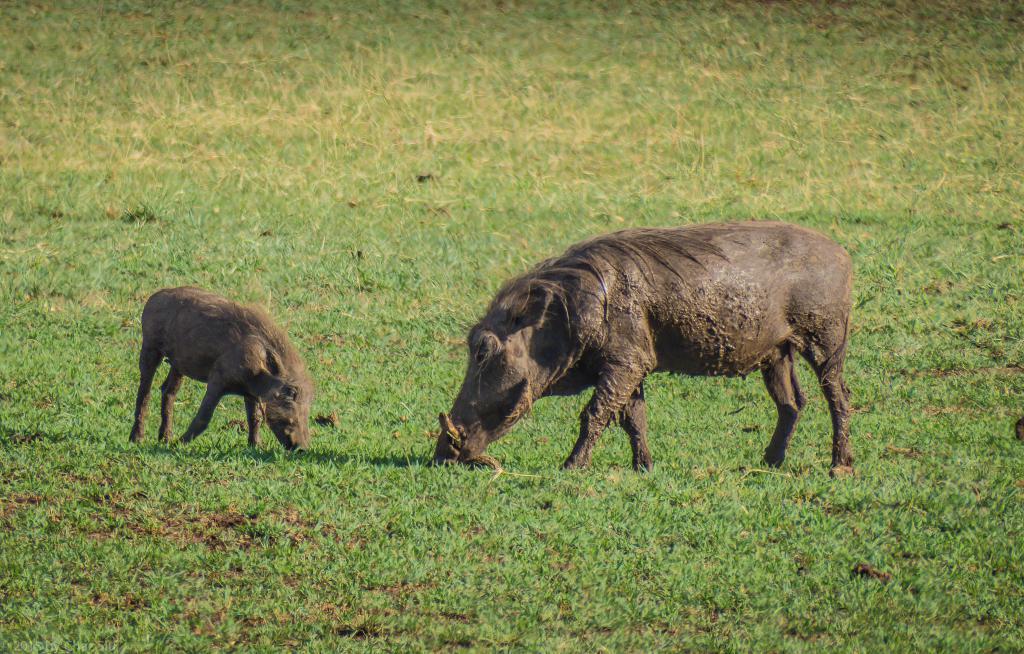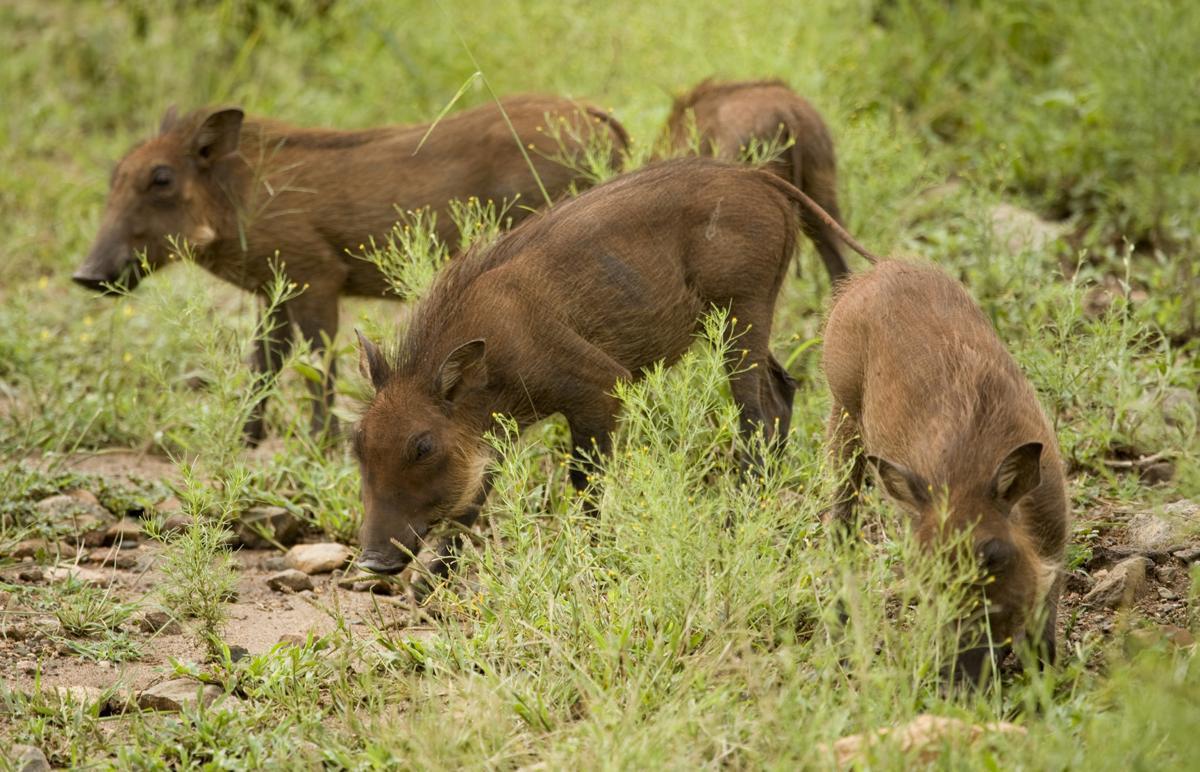The first image is the image on the left, the second image is the image on the right. Considering the images on both sides, is "One of the images contains only one boar." valid? Answer yes or no. No. 